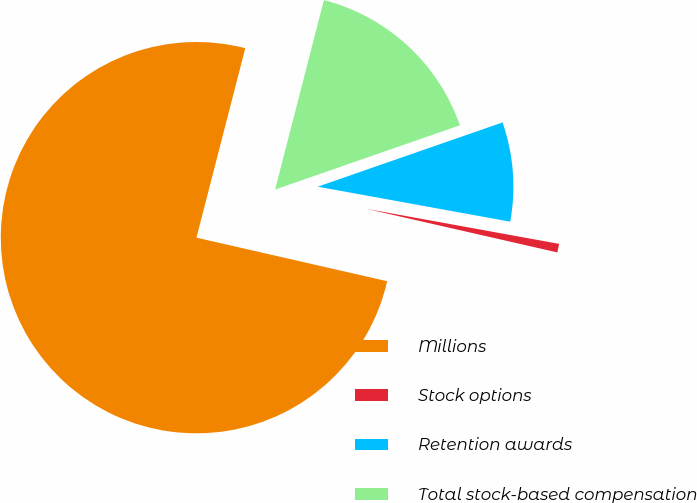Convert chart to OTSL. <chart><loc_0><loc_0><loc_500><loc_500><pie_chart><fcel>Millions<fcel>Stock options<fcel>Retention awards<fcel>Total stock-based compensation<nl><fcel>75.44%<fcel>0.71%<fcel>8.19%<fcel>15.66%<nl></chart> 